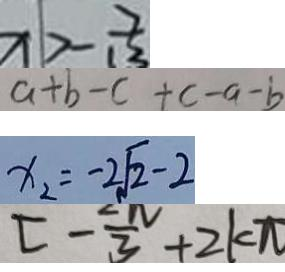Convert formula to latex. <formula><loc_0><loc_0><loc_500><loc_500>x > - \frac { 7 } { 1 2 } 
 a + b - c + c - a - b 
 x _ { 2 } = - 2 \sqrt { 2 } - 2 
 [ - \frac { 2 \pi } { 3 } + 2 k \pi</formula> 